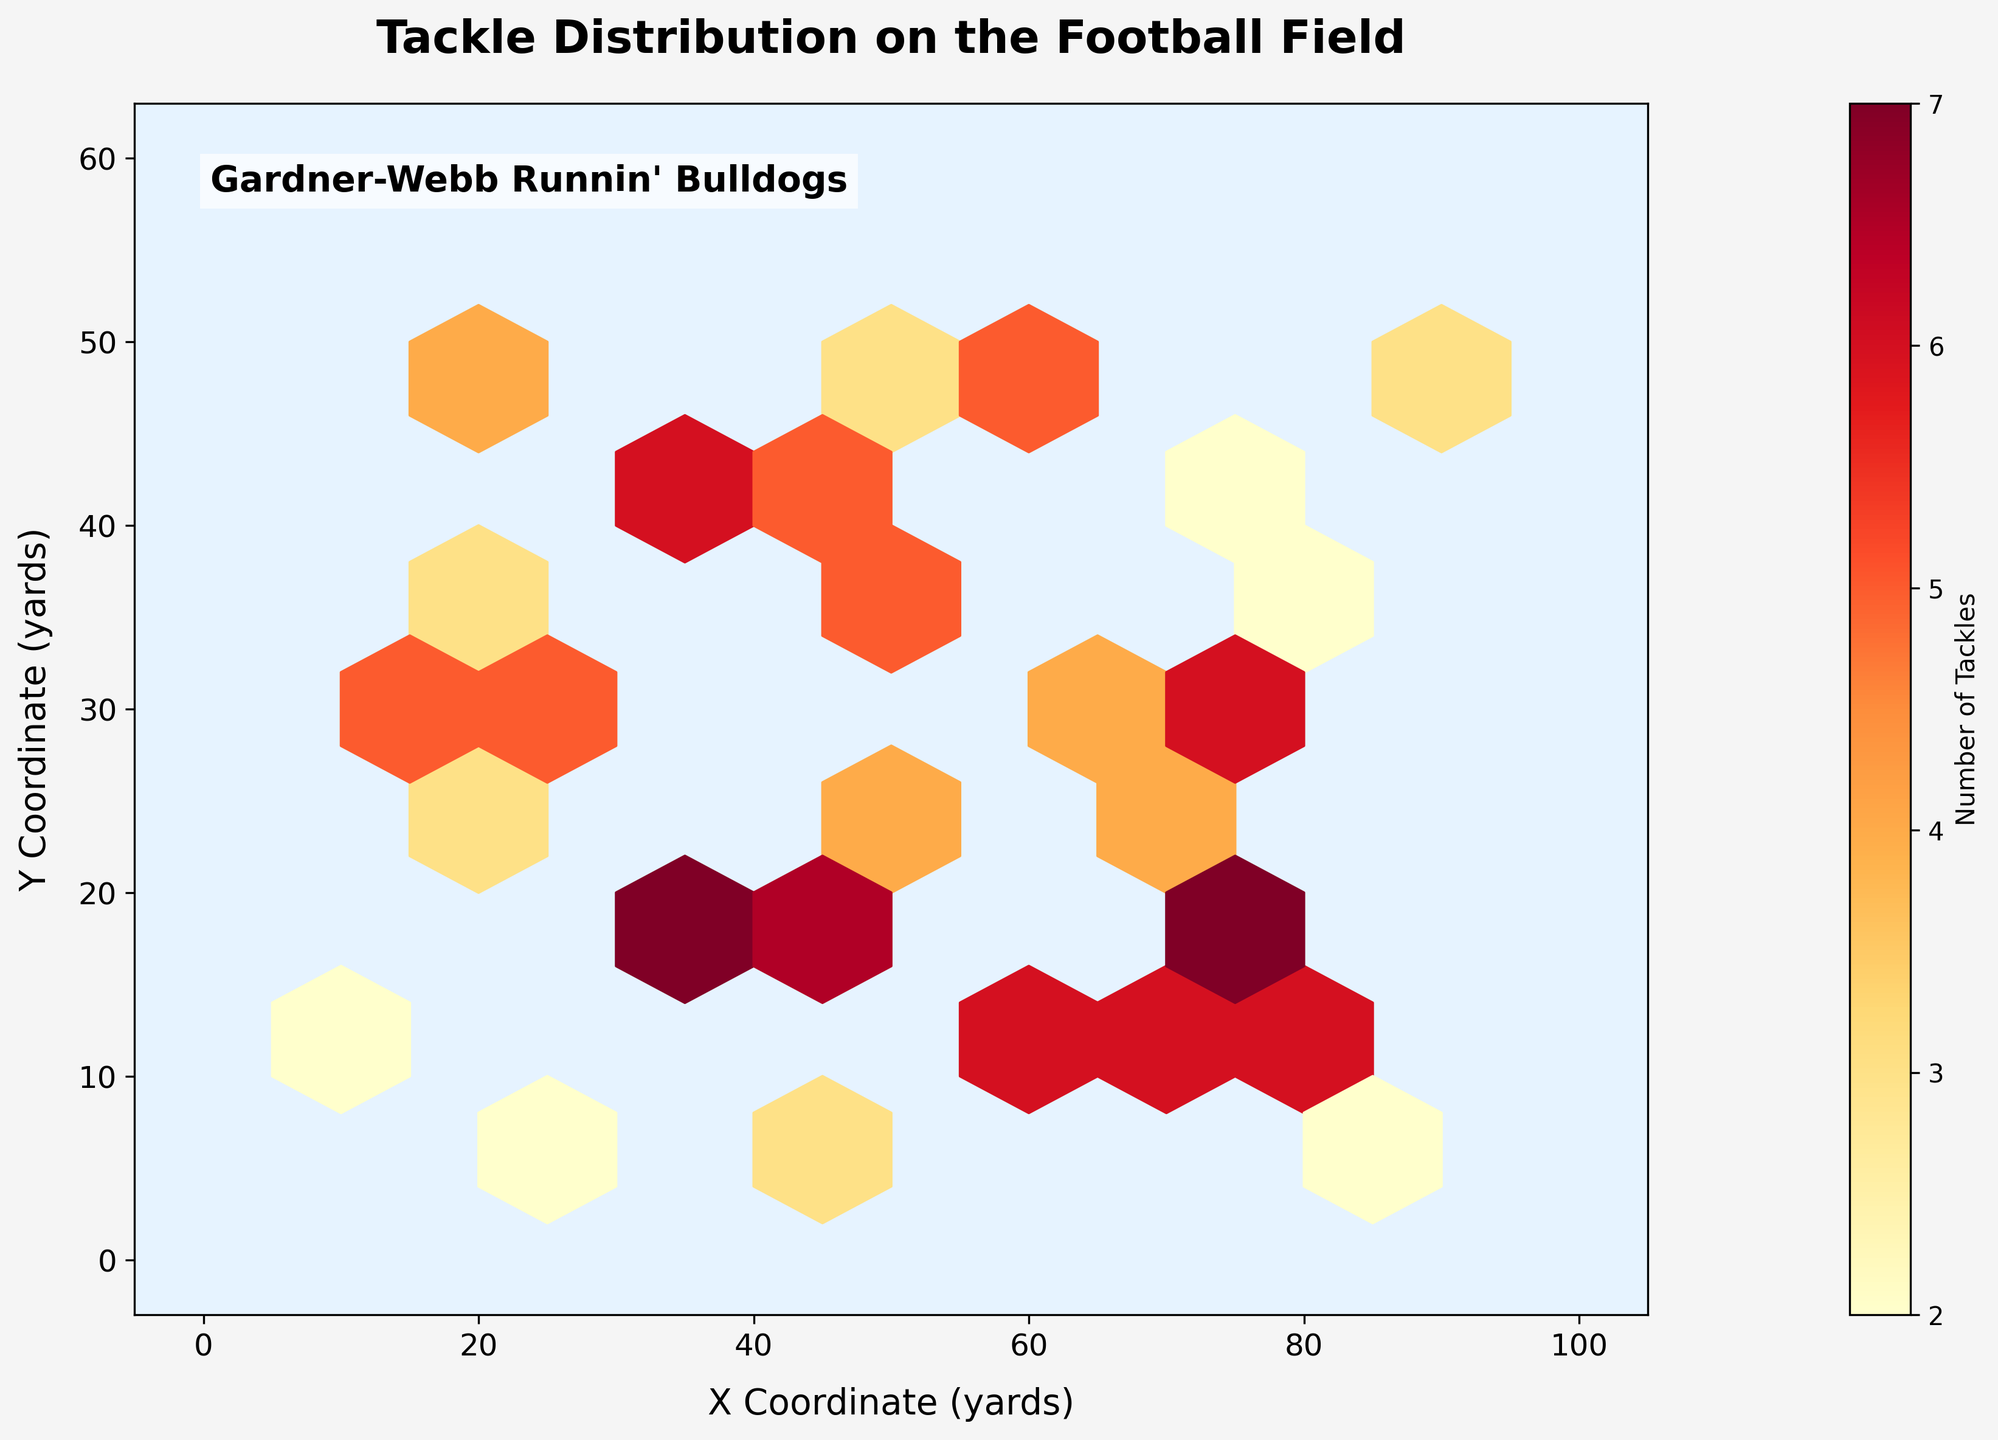What's the title of the figure? The title of a figure is typically displayed at the top. In this case, the title is written as "Tackle Distribution on the Football Field".
Answer: "Tackle Distribution on the Football Field" What are the labels of the axes? Axes labels provide information on what the x and y coordinates represent. The x-axis is labeled "X Coordinate (yards)" and the y-axis is labeled "Y Coordinate (yards)".
Answer: "X Coordinate (yards)" and "Y Coordinate (yards)" What does the color intensity represent in the hexbin plot? In a hexbin plot, color intensity is often used to represent the concentration or count of elements. Here, the color intensity represents the number of tackles.
Answer: Number of tackles Where is the highest concentration of tackles located on the field? The highest concentration of tackles can be identified by the darkest hexagonal bins. Based on the figure data, these are located around the hexbin at coordinates (25, 30) and (35, 20).
Answer: Around coordinates (25, 30) and (35, 20) Which color represents the highest number of tackles? In the color map "YlOrRd", yellow represents lower values and red represents higher values. Therefore, red represents the highest number of tackles.
Answer: Red Which data point has the highest number of tackles? The data point with the highest number of tackles can be seen by looking at the individual numbers for tackles in the dataset. The highest value is 8, which is at coordinates (30, 40).
Answer: (30, 40) What is the coordinate range covered by the hexbin plot? The extent of the plot is provided which encompasses the values on the x-axis and y-axis. The x-coordinate ranges from 0 to 100 yards and the y-coordinate ranges from 0 to 60 yards.
Answer: x: 0-100 yards, y: 0-60 yards How many hexagons have a tackle count of at least 5? By looking at the color bar and understanding the figure, we can count the bins that have colors corresponding to a count of at least 5. From the plot, there are multiple hexagons with color intensities representing 5 or more. Visual estimation from the distribution suggests about 10.
Answer: About 10 hexagons Is there a higher number of tackles in the top half or bottom half of the field? To answer this, we compare the concentration of tackles above and below the midline of the field. The distribution suggests a slightly higher concentration in the bottom half (below 30 yards on the y-coordinate).
Answer: Bottom half Which coordinate (x, y) has a moderate (4-6) count of tackles? By observing the color gradient and comparing it to the color bar, we can identify coordinates with bins colored in the range corresponding to 4-6 tackles, such as coordinates around (55, 25) and (60, 10).
Answer: (55, 25) and (60, 10) 